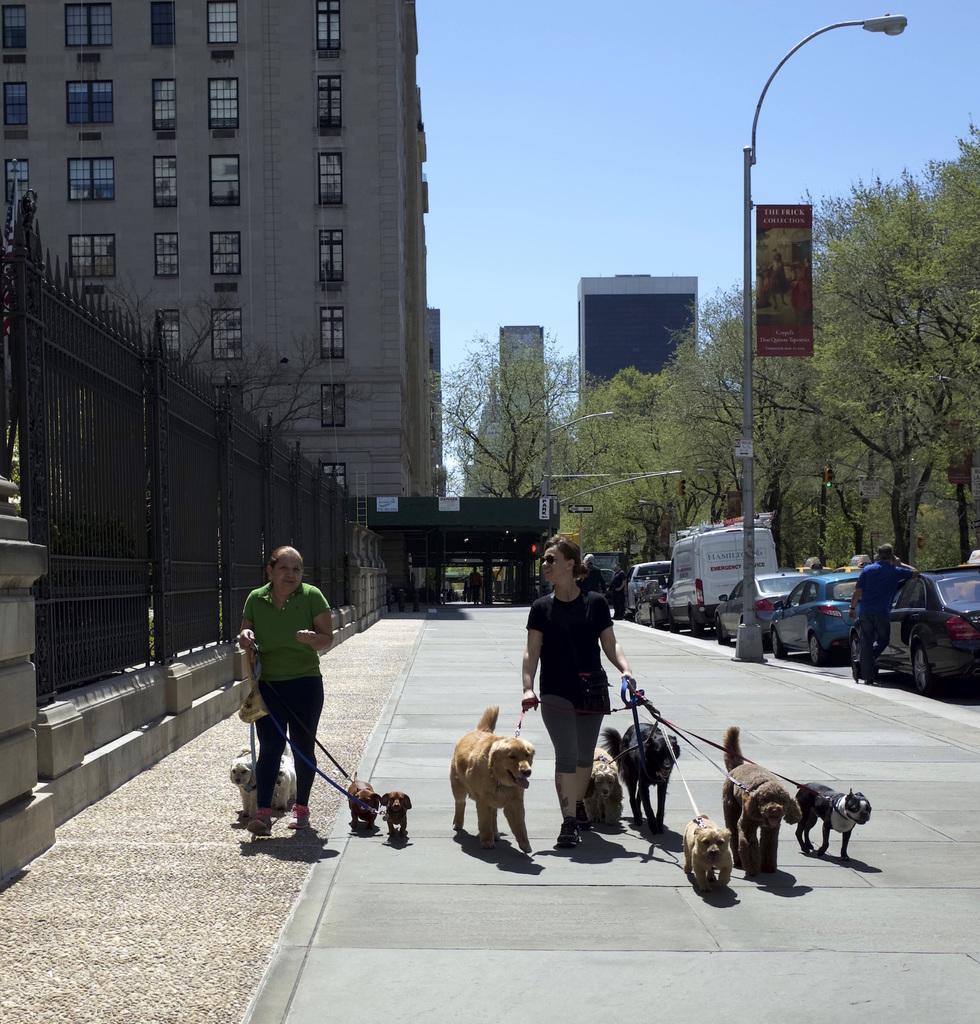Can you describe this image briefly? This image is taken outdoors. At the top of the image there is the sky. At the bottom of the image there is floor. In the background there are three buildings with walls and windows. There are a few trees with leaves, stems and branches. There is a pole with a street light. There is a board with a text on it. There are a few pillars. There are a few grills. On the right side of the image many vehicles are parked on the road and there are a few people. In the middle of the image two women are walking on the floor and they are holding a few belts in their hands which are tired around in the necks of the dogs. 